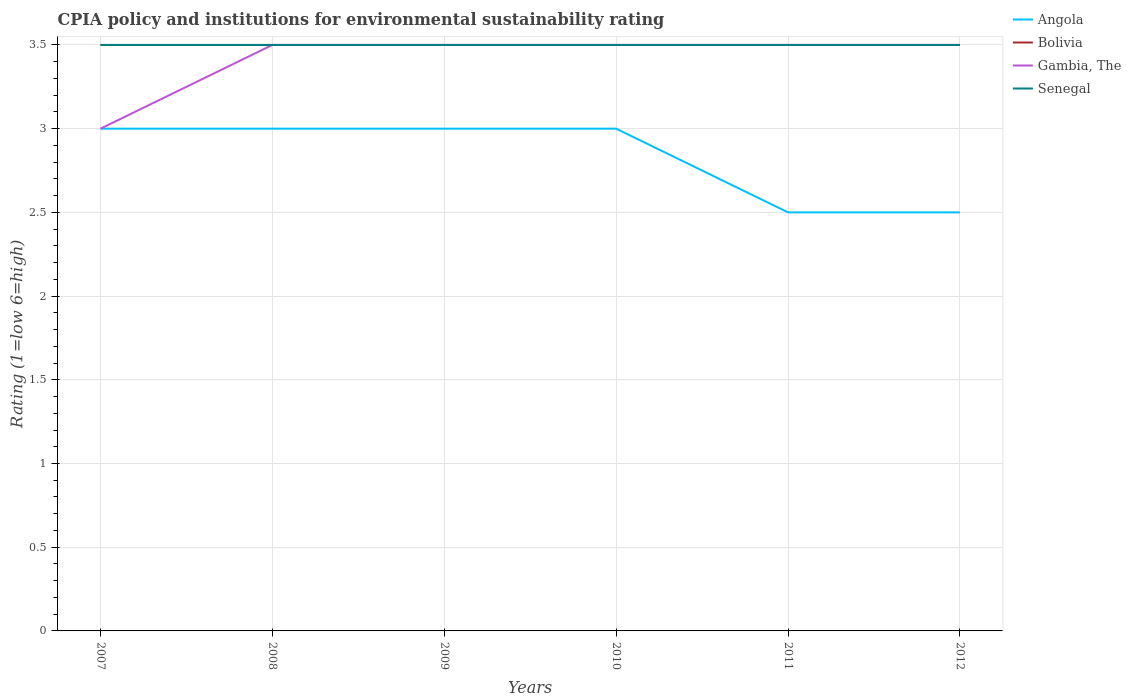How many different coloured lines are there?
Keep it short and to the point. 4. Does the line corresponding to Bolivia intersect with the line corresponding to Senegal?
Your response must be concise. Yes. What is the difference between the highest and the second highest CPIA rating in Angola?
Offer a very short reply. 0.5. What is the difference between the highest and the lowest CPIA rating in Senegal?
Give a very brief answer. 0. Is the CPIA rating in Senegal strictly greater than the CPIA rating in Gambia, The over the years?
Your answer should be very brief. No. How many lines are there?
Keep it short and to the point. 4. How many years are there in the graph?
Offer a terse response. 6. What is the difference between two consecutive major ticks on the Y-axis?
Offer a very short reply. 0.5. Does the graph contain any zero values?
Provide a short and direct response. No. What is the title of the graph?
Offer a terse response. CPIA policy and institutions for environmental sustainability rating. What is the label or title of the X-axis?
Provide a short and direct response. Years. What is the Rating (1=low 6=high) of Gambia, The in 2007?
Provide a succinct answer. 3. What is the Rating (1=low 6=high) in Senegal in 2007?
Your answer should be compact. 3.5. What is the Rating (1=low 6=high) in Bolivia in 2008?
Your answer should be compact. 3.5. What is the Rating (1=low 6=high) in Gambia, The in 2008?
Make the answer very short. 3.5. What is the Rating (1=low 6=high) of Senegal in 2008?
Provide a succinct answer. 3.5. What is the Rating (1=low 6=high) of Bolivia in 2009?
Your answer should be compact. 3.5. What is the Rating (1=low 6=high) of Gambia, The in 2009?
Your response must be concise. 3.5. What is the Rating (1=low 6=high) in Senegal in 2009?
Offer a very short reply. 3.5. What is the Rating (1=low 6=high) of Angola in 2010?
Keep it short and to the point. 3. What is the Rating (1=low 6=high) of Gambia, The in 2010?
Your response must be concise. 3.5. What is the Rating (1=low 6=high) in Senegal in 2011?
Your answer should be compact. 3.5. What is the Rating (1=low 6=high) in Bolivia in 2012?
Your answer should be compact. 3.5. What is the Rating (1=low 6=high) in Senegal in 2012?
Provide a succinct answer. 3.5. Across all years, what is the maximum Rating (1=low 6=high) of Angola?
Your answer should be compact. 3. Across all years, what is the minimum Rating (1=low 6=high) of Senegal?
Your answer should be compact. 3.5. What is the total Rating (1=low 6=high) of Gambia, The in the graph?
Provide a short and direct response. 20.5. What is the difference between the Rating (1=low 6=high) of Angola in 2007 and that in 2008?
Your answer should be very brief. 0. What is the difference between the Rating (1=low 6=high) in Bolivia in 2007 and that in 2008?
Provide a succinct answer. 0. What is the difference between the Rating (1=low 6=high) in Senegal in 2007 and that in 2008?
Give a very brief answer. 0. What is the difference between the Rating (1=low 6=high) of Bolivia in 2007 and that in 2009?
Provide a succinct answer. 0. What is the difference between the Rating (1=low 6=high) in Gambia, The in 2007 and that in 2009?
Your answer should be very brief. -0.5. What is the difference between the Rating (1=low 6=high) of Senegal in 2007 and that in 2009?
Give a very brief answer. 0. What is the difference between the Rating (1=low 6=high) in Bolivia in 2007 and that in 2010?
Keep it short and to the point. 0. What is the difference between the Rating (1=low 6=high) of Gambia, The in 2007 and that in 2010?
Provide a succinct answer. -0.5. What is the difference between the Rating (1=low 6=high) in Senegal in 2007 and that in 2011?
Make the answer very short. 0. What is the difference between the Rating (1=low 6=high) of Angola in 2007 and that in 2012?
Make the answer very short. 0.5. What is the difference between the Rating (1=low 6=high) in Angola in 2008 and that in 2009?
Provide a succinct answer. 0. What is the difference between the Rating (1=low 6=high) in Bolivia in 2008 and that in 2009?
Make the answer very short. 0. What is the difference between the Rating (1=low 6=high) in Senegal in 2008 and that in 2009?
Your response must be concise. 0. What is the difference between the Rating (1=low 6=high) of Angola in 2008 and that in 2010?
Give a very brief answer. 0. What is the difference between the Rating (1=low 6=high) in Angola in 2008 and that in 2012?
Offer a very short reply. 0.5. What is the difference between the Rating (1=low 6=high) in Gambia, The in 2008 and that in 2012?
Ensure brevity in your answer.  0. What is the difference between the Rating (1=low 6=high) of Angola in 2009 and that in 2010?
Offer a very short reply. 0. What is the difference between the Rating (1=low 6=high) of Bolivia in 2009 and that in 2010?
Provide a succinct answer. 0. What is the difference between the Rating (1=low 6=high) of Gambia, The in 2009 and that in 2010?
Give a very brief answer. 0. What is the difference between the Rating (1=low 6=high) of Senegal in 2009 and that in 2010?
Ensure brevity in your answer.  0. What is the difference between the Rating (1=low 6=high) in Angola in 2009 and that in 2011?
Offer a terse response. 0.5. What is the difference between the Rating (1=low 6=high) in Bolivia in 2009 and that in 2011?
Make the answer very short. 0. What is the difference between the Rating (1=low 6=high) of Gambia, The in 2009 and that in 2011?
Provide a succinct answer. 0. What is the difference between the Rating (1=low 6=high) of Bolivia in 2009 and that in 2012?
Provide a short and direct response. 0. What is the difference between the Rating (1=low 6=high) of Senegal in 2009 and that in 2012?
Keep it short and to the point. 0. What is the difference between the Rating (1=low 6=high) of Angola in 2010 and that in 2011?
Your response must be concise. 0.5. What is the difference between the Rating (1=low 6=high) in Bolivia in 2010 and that in 2011?
Keep it short and to the point. 0. What is the difference between the Rating (1=low 6=high) in Gambia, The in 2010 and that in 2011?
Provide a succinct answer. 0. What is the difference between the Rating (1=low 6=high) of Angola in 2010 and that in 2012?
Ensure brevity in your answer.  0.5. What is the difference between the Rating (1=low 6=high) of Gambia, The in 2010 and that in 2012?
Offer a very short reply. 0. What is the difference between the Rating (1=low 6=high) of Angola in 2011 and that in 2012?
Your answer should be compact. 0. What is the difference between the Rating (1=low 6=high) in Gambia, The in 2011 and that in 2012?
Provide a short and direct response. 0. What is the difference between the Rating (1=low 6=high) of Senegal in 2011 and that in 2012?
Make the answer very short. 0. What is the difference between the Rating (1=low 6=high) of Angola in 2007 and the Rating (1=low 6=high) of Bolivia in 2008?
Give a very brief answer. -0.5. What is the difference between the Rating (1=low 6=high) in Angola in 2007 and the Rating (1=low 6=high) in Gambia, The in 2008?
Your answer should be compact. -0.5. What is the difference between the Rating (1=low 6=high) in Bolivia in 2007 and the Rating (1=low 6=high) in Gambia, The in 2008?
Your response must be concise. 0. What is the difference between the Rating (1=low 6=high) of Gambia, The in 2007 and the Rating (1=low 6=high) of Senegal in 2008?
Offer a very short reply. -0.5. What is the difference between the Rating (1=low 6=high) of Angola in 2007 and the Rating (1=low 6=high) of Gambia, The in 2009?
Ensure brevity in your answer.  -0.5. What is the difference between the Rating (1=low 6=high) in Angola in 2007 and the Rating (1=low 6=high) in Senegal in 2009?
Ensure brevity in your answer.  -0.5. What is the difference between the Rating (1=low 6=high) in Bolivia in 2007 and the Rating (1=low 6=high) in Gambia, The in 2009?
Offer a very short reply. 0. What is the difference between the Rating (1=low 6=high) in Bolivia in 2007 and the Rating (1=low 6=high) in Senegal in 2009?
Keep it short and to the point. 0. What is the difference between the Rating (1=low 6=high) of Angola in 2007 and the Rating (1=low 6=high) of Gambia, The in 2010?
Ensure brevity in your answer.  -0.5. What is the difference between the Rating (1=low 6=high) in Bolivia in 2007 and the Rating (1=low 6=high) in Gambia, The in 2010?
Offer a terse response. 0. What is the difference between the Rating (1=low 6=high) of Angola in 2007 and the Rating (1=low 6=high) of Bolivia in 2011?
Offer a terse response. -0.5. What is the difference between the Rating (1=low 6=high) of Angola in 2007 and the Rating (1=low 6=high) of Gambia, The in 2011?
Keep it short and to the point. -0.5. What is the difference between the Rating (1=low 6=high) in Angola in 2007 and the Rating (1=low 6=high) in Senegal in 2011?
Offer a very short reply. -0.5. What is the difference between the Rating (1=low 6=high) of Bolivia in 2007 and the Rating (1=low 6=high) of Gambia, The in 2011?
Offer a very short reply. 0. What is the difference between the Rating (1=low 6=high) of Bolivia in 2007 and the Rating (1=low 6=high) of Senegal in 2011?
Give a very brief answer. 0. What is the difference between the Rating (1=low 6=high) of Gambia, The in 2007 and the Rating (1=low 6=high) of Senegal in 2011?
Ensure brevity in your answer.  -0.5. What is the difference between the Rating (1=low 6=high) of Angola in 2007 and the Rating (1=low 6=high) of Senegal in 2012?
Ensure brevity in your answer.  -0.5. What is the difference between the Rating (1=low 6=high) in Bolivia in 2007 and the Rating (1=low 6=high) in Gambia, The in 2012?
Provide a short and direct response. 0. What is the difference between the Rating (1=low 6=high) of Bolivia in 2008 and the Rating (1=low 6=high) of Senegal in 2009?
Ensure brevity in your answer.  0. What is the difference between the Rating (1=low 6=high) in Gambia, The in 2008 and the Rating (1=low 6=high) in Senegal in 2009?
Give a very brief answer. 0. What is the difference between the Rating (1=low 6=high) of Angola in 2008 and the Rating (1=low 6=high) of Bolivia in 2010?
Provide a short and direct response. -0.5. What is the difference between the Rating (1=low 6=high) in Angola in 2008 and the Rating (1=low 6=high) in Gambia, The in 2010?
Make the answer very short. -0.5. What is the difference between the Rating (1=low 6=high) in Angola in 2008 and the Rating (1=low 6=high) in Senegal in 2010?
Make the answer very short. -0.5. What is the difference between the Rating (1=low 6=high) of Bolivia in 2008 and the Rating (1=low 6=high) of Gambia, The in 2010?
Keep it short and to the point. 0. What is the difference between the Rating (1=low 6=high) in Angola in 2008 and the Rating (1=low 6=high) in Senegal in 2011?
Your answer should be compact. -0.5. What is the difference between the Rating (1=low 6=high) of Bolivia in 2008 and the Rating (1=low 6=high) of Senegal in 2011?
Provide a short and direct response. 0. What is the difference between the Rating (1=low 6=high) in Angola in 2008 and the Rating (1=low 6=high) in Bolivia in 2012?
Your response must be concise. -0.5. What is the difference between the Rating (1=low 6=high) in Angola in 2008 and the Rating (1=low 6=high) in Gambia, The in 2012?
Offer a very short reply. -0.5. What is the difference between the Rating (1=low 6=high) of Angola in 2008 and the Rating (1=low 6=high) of Senegal in 2012?
Give a very brief answer. -0.5. What is the difference between the Rating (1=low 6=high) of Angola in 2009 and the Rating (1=low 6=high) of Bolivia in 2010?
Keep it short and to the point. -0.5. What is the difference between the Rating (1=low 6=high) of Angola in 2009 and the Rating (1=low 6=high) of Gambia, The in 2010?
Offer a terse response. -0.5. What is the difference between the Rating (1=low 6=high) in Angola in 2009 and the Rating (1=low 6=high) in Senegal in 2010?
Provide a short and direct response. -0.5. What is the difference between the Rating (1=low 6=high) in Bolivia in 2009 and the Rating (1=low 6=high) in Gambia, The in 2011?
Give a very brief answer. 0. What is the difference between the Rating (1=low 6=high) of Gambia, The in 2009 and the Rating (1=low 6=high) of Senegal in 2011?
Offer a terse response. 0. What is the difference between the Rating (1=low 6=high) in Angola in 2009 and the Rating (1=low 6=high) in Gambia, The in 2012?
Give a very brief answer. -0.5. What is the difference between the Rating (1=low 6=high) in Bolivia in 2009 and the Rating (1=low 6=high) in Gambia, The in 2012?
Your response must be concise. 0. What is the difference between the Rating (1=low 6=high) of Bolivia in 2009 and the Rating (1=low 6=high) of Senegal in 2012?
Keep it short and to the point. 0. What is the difference between the Rating (1=low 6=high) of Gambia, The in 2009 and the Rating (1=low 6=high) of Senegal in 2012?
Your answer should be very brief. 0. What is the difference between the Rating (1=low 6=high) of Angola in 2010 and the Rating (1=low 6=high) of Bolivia in 2011?
Your answer should be very brief. -0.5. What is the difference between the Rating (1=low 6=high) in Gambia, The in 2010 and the Rating (1=low 6=high) in Senegal in 2011?
Give a very brief answer. 0. What is the difference between the Rating (1=low 6=high) of Angola in 2010 and the Rating (1=low 6=high) of Gambia, The in 2012?
Give a very brief answer. -0.5. What is the difference between the Rating (1=low 6=high) of Bolivia in 2010 and the Rating (1=low 6=high) of Senegal in 2012?
Keep it short and to the point. 0. What is the difference between the Rating (1=low 6=high) in Bolivia in 2011 and the Rating (1=low 6=high) in Gambia, The in 2012?
Your answer should be very brief. 0. What is the difference between the Rating (1=low 6=high) in Bolivia in 2011 and the Rating (1=low 6=high) in Senegal in 2012?
Your answer should be compact. 0. What is the difference between the Rating (1=low 6=high) in Gambia, The in 2011 and the Rating (1=low 6=high) in Senegal in 2012?
Your response must be concise. 0. What is the average Rating (1=low 6=high) of Angola per year?
Offer a very short reply. 2.83. What is the average Rating (1=low 6=high) in Bolivia per year?
Make the answer very short. 3.5. What is the average Rating (1=low 6=high) of Gambia, The per year?
Provide a succinct answer. 3.42. What is the average Rating (1=low 6=high) of Senegal per year?
Offer a very short reply. 3.5. In the year 2007, what is the difference between the Rating (1=low 6=high) in Angola and Rating (1=low 6=high) in Gambia, The?
Your answer should be very brief. 0. In the year 2007, what is the difference between the Rating (1=low 6=high) in Angola and Rating (1=low 6=high) in Senegal?
Keep it short and to the point. -0.5. In the year 2008, what is the difference between the Rating (1=low 6=high) of Angola and Rating (1=low 6=high) of Senegal?
Make the answer very short. -0.5. In the year 2008, what is the difference between the Rating (1=low 6=high) of Bolivia and Rating (1=low 6=high) of Gambia, The?
Keep it short and to the point. 0. In the year 2008, what is the difference between the Rating (1=low 6=high) of Bolivia and Rating (1=low 6=high) of Senegal?
Offer a terse response. 0. In the year 2008, what is the difference between the Rating (1=low 6=high) in Gambia, The and Rating (1=low 6=high) in Senegal?
Your response must be concise. 0. In the year 2009, what is the difference between the Rating (1=low 6=high) of Angola and Rating (1=low 6=high) of Bolivia?
Provide a succinct answer. -0.5. In the year 2009, what is the difference between the Rating (1=low 6=high) in Angola and Rating (1=low 6=high) in Gambia, The?
Offer a very short reply. -0.5. In the year 2009, what is the difference between the Rating (1=low 6=high) of Angola and Rating (1=low 6=high) of Senegal?
Your response must be concise. -0.5. In the year 2009, what is the difference between the Rating (1=low 6=high) in Bolivia and Rating (1=low 6=high) in Gambia, The?
Your answer should be very brief. 0. In the year 2009, what is the difference between the Rating (1=low 6=high) of Bolivia and Rating (1=low 6=high) of Senegal?
Give a very brief answer. 0. In the year 2010, what is the difference between the Rating (1=low 6=high) of Angola and Rating (1=low 6=high) of Senegal?
Give a very brief answer. -0.5. In the year 2010, what is the difference between the Rating (1=low 6=high) in Gambia, The and Rating (1=low 6=high) in Senegal?
Ensure brevity in your answer.  0. In the year 2011, what is the difference between the Rating (1=low 6=high) in Angola and Rating (1=low 6=high) in Senegal?
Offer a terse response. -1. In the year 2011, what is the difference between the Rating (1=low 6=high) in Bolivia and Rating (1=low 6=high) in Senegal?
Offer a very short reply. 0. In the year 2012, what is the difference between the Rating (1=low 6=high) of Angola and Rating (1=low 6=high) of Gambia, The?
Offer a very short reply. -1. In the year 2012, what is the difference between the Rating (1=low 6=high) of Angola and Rating (1=low 6=high) of Senegal?
Your answer should be very brief. -1. In the year 2012, what is the difference between the Rating (1=low 6=high) in Bolivia and Rating (1=low 6=high) in Gambia, The?
Provide a short and direct response. 0. What is the ratio of the Rating (1=low 6=high) of Angola in 2007 to that in 2008?
Ensure brevity in your answer.  1. What is the ratio of the Rating (1=low 6=high) in Angola in 2007 to that in 2009?
Provide a short and direct response. 1. What is the ratio of the Rating (1=low 6=high) of Bolivia in 2007 to that in 2009?
Offer a terse response. 1. What is the ratio of the Rating (1=low 6=high) in Gambia, The in 2007 to that in 2009?
Keep it short and to the point. 0.86. What is the ratio of the Rating (1=low 6=high) of Angola in 2007 to that in 2010?
Provide a succinct answer. 1. What is the ratio of the Rating (1=low 6=high) in Bolivia in 2007 to that in 2010?
Offer a very short reply. 1. What is the ratio of the Rating (1=low 6=high) in Gambia, The in 2007 to that in 2010?
Ensure brevity in your answer.  0.86. What is the ratio of the Rating (1=low 6=high) in Senegal in 2007 to that in 2011?
Ensure brevity in your answer.  1. What is the ratio of the Rating (1=low 6=high) in Bolivia in 2007 to that in 2012?
Your response must be concise. 1. What is the ratio of the Rating (1=low 6=high) in Gambia, The in 2007 to that in 2012?
Ensure brevity in your answer.  0.86. What is the ratio of the Rating (1=low 6=high) of Angola in 2008 to that in 2009?
Provide a short and direct response. 1. What is the ratio of the Rating (1=low 6=high) in Gambia, The in 2008 to that in 2009?
Provide a succinct answer. 1. What is the ratio of the Rating (1=low 6=high) of Senegal in 2008 to that in 2009?
Ensure brevity in your answer.  1. What is the ratio of the Rating (1=low 6=high) of Bolivia in 2008 to that in 2010?
Offer a terse response. 1. What is the ratio of the Rating (1=low 6=high) of Gambia, The in 2008 to that in 2010?
Provide a succinct answer. 1. What is the ratio of the Rating (1=low 6=high) in Gambia, The in 2008 to that in 2011?
Provide a short and direct response. 1. What is the ratio of the Rating (1=low 6=high) of Senegal in 2008 to that in 2011?
Offer a very short reply. 1. What is the ratio of the Rating (1=low 6=high) of Bolivia in 2008 to that in 2012?
Your response must be concise. 1. What is the ratio of the Rating (1=low 6=high) in Gambia, The in 2008 to that in 2012?
Your response must be concise. 1. What is the ratio of the Rating (1=low 6=high) of Senegal in 2008 to that in 2012?
Your response must be concise. 1. What is the ratio of the Rating (1=low 6=high) of Angola in 2009 to that in 2010?
Your answer should be very brief. 1. What is the ratio of the Rating (1=low 6=high) in Bolivia in 2009 to that in 2010?
Your answer should be compact. 1. What is the ratio of the Rating (1=low 6=high) in Senegal in 2009 to that in 2010?
Your response must be concise. 1. What is the ratio of the Rating (1=low 6=high) in Bolivia in 2009 to that in 2011?
Give a very brief answer. 1. What is the ratio of the Rating (1=low 6=high) in Gambia, The in 2009 to that in 2011?
Your answer should be very brief. 1. What is the ratio of the Rating (1=low 6=high) of Senegal in 2009 to that in 2011?
Make the answer very short. 1. What is the ratio of the Rating (1=low 6=high) in Angola in 2009 to that in 2012?
Your answer should be very brief. 1.2. What is the ratio of the Rating (1=low 6=high) in Senegal in 2009 to that in 2012?
Offer a terse response. 1. What is the ratio of the Rating (1=low 6=high) of Angola in 2010 to that in 2011?
Make the answer very short. 1.2. What is the ratio of the Rating (1=low 6=high) in Bolivia in 2010 to that in 2011?
Make the answer very short. 1. What is the ratio of the Rating (1=low 6=high) of Angola in 2010 to that in 2012?
Offer a terse response. 1.2. What is the ratio of the Rating (1=low 6=high) of Bolivia in 2010 to that in 2012?
Your response must be concise. 1. What is the ratio of the Rating (1=low 6=high) of Senegal in 2010 to that in 2012?
Your response must be concise. 1. What is the ratio of the Rating (1=low 6=high) of Angola in 2011 to that in 2012?
Provide a short and direct response. 1. What is the ratio of the Rating (1=low 6=high) of Senegal in 2011 to that in 2012?
Give a very brief answer. 1. What is the difference between the highest and the second highest Rating (1=low 6=high) in Angola?
Ensure brevity in your answer.  0. What is the difference between the highest and the second highest Rating (1=low 6=high) in Bolivia?
Your response must be concise. 0. What is the difference between the highest and the lowest Rating (1=low 6=high) of Bolivia?
Give a very brief answer. 0. What is the difference between the highest and the lowest Rating (1=low 6=high) in Gambia, The?
Provide a short and direct response. 0.5. 